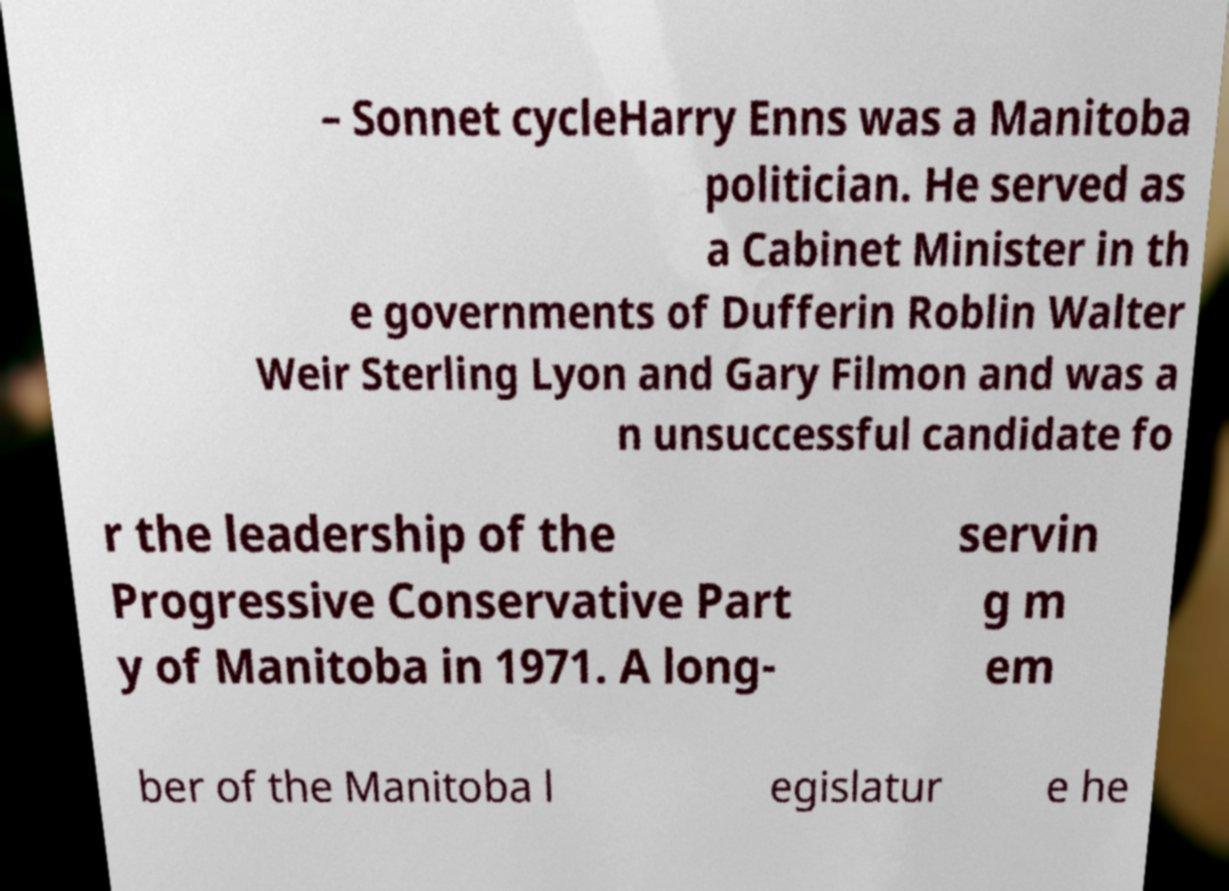Please read and relay the text visible in this image. What does it say? – Sonnet cycleHarry Enns was a Manitoba politician. He served as a Cabinet Minister in th e governments of Dufferin Roblin Walter Weir Sterling Lyon and Gary Filmon and was a n unsuccessful candidate fo r the leadership of the Progressive Conservative Part y of Manitoba in 1971. A long- servin g m em ber of the Manitoba l egislatur e he 